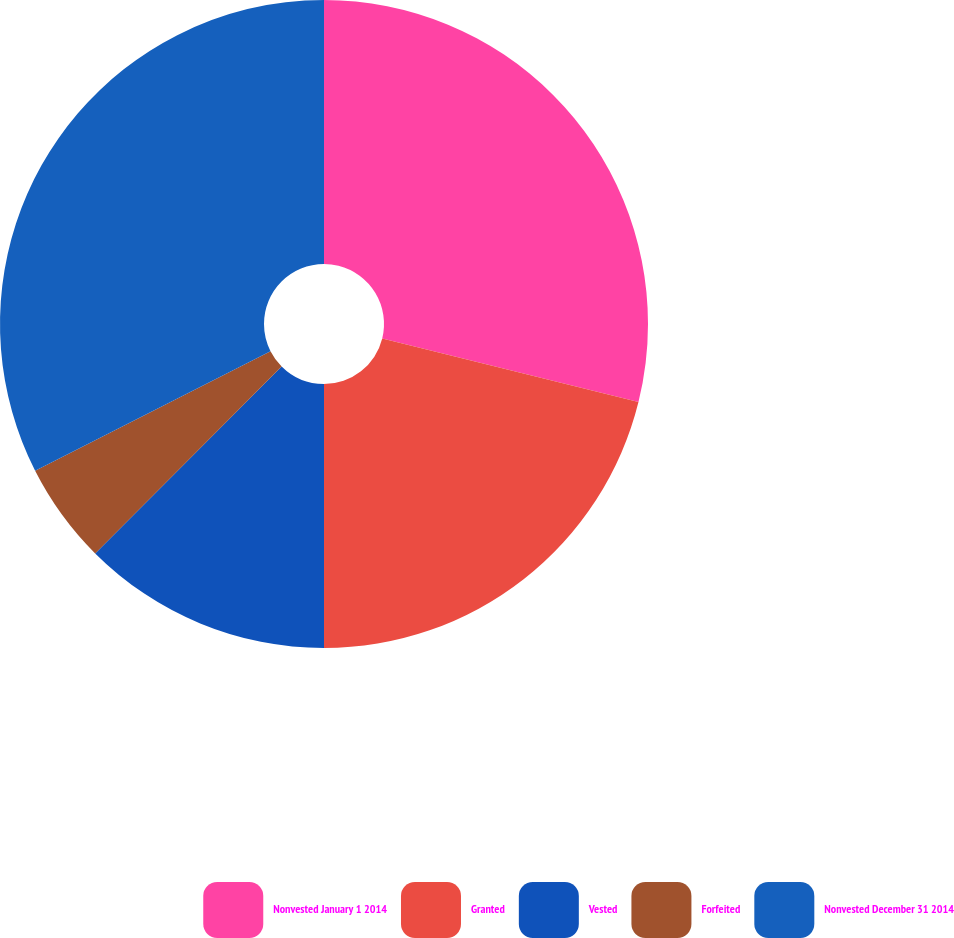Convert chart to OTSL. <chart><loc_0><loc_0><loc_500><loc_500><pie_chart><fcel>Nonvested January 1 2014<fcel>Granted<fcel>Vested<fcel>Forfeited<fcel>Nonvested December 31 2014<nl><fcel>28.87%<fcel>21.13%<fcel>12.48%<fcel>5.04%<fcel>32.48%<nl></chart> 